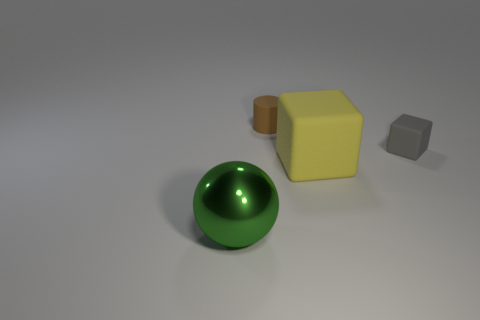Add 4 yellow rubber things. How many objects exist? 8 Subtract 1 cylinders. How many cylinders are left? 0 Subtract all brown blocks. Subtract all blue cylinders. How many blocks are left? 2 Subtract all cyan blocks. How many purple balls are left? 0 Subtract all gray matte things. Subtract all shiny balls. How many objects are left? 2 Add 1 small brown matte things. How many small brown matte things are left? 2 Add 1 green things. How many green things exist? 2 Subtract all yellow cubes. How many cubes are left? 1 Subtract 0 cyan balls. How many objects are left? 4 